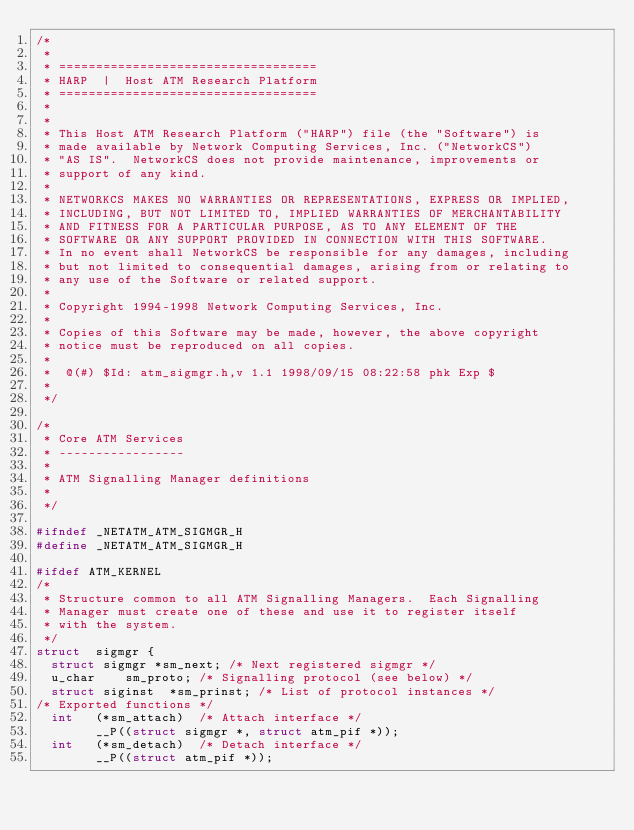<code> <loc_0><loc_0><loc_500><loc_500><_C_>/*
 *
 * ===================================
 * HARP  |  Host ATM Research Platform
 * ===================================
 *
 *
 * This Host ATM Research Platform ("HARP") file (the "Software") is
 * made available by Network Computing Services, Inc. ("NetworkCS")
 * "AS IS".  NetworkCS does not provide maintenance, improvements or
 * support of any kind.
 *
 * NETWORKCS MAKES NO WARRANTIES OR REPRESENTATIONS, EXPRESS OR IMPLIED,
 * INCLUDING, BUT NOT LIMITED TO, IMPLIED WARRANTIES OF MERCHANTABILITY
 * AND FITNESS FOR A PARTICULAR PURPOSE, AS TO ANY ELEMENT OF THE
 * SOFTWARE OR ANY SUPPORT PROVIDED IN CONNECTION WITH THIS SOFTWARE.
 * In no event shall NetworkCS be responsible for any damages, including
 * but not limited to consequential damages, arising from or relating to
 * any use of the Software or related support.
 *
 * Copyright 1994-1998 Network Computing Services, Inc.
 *
 * Copies of this Software may be made, however, the above copyright
 * notice must be reproduced on all copies.
 *
 *	@(#) $Id: atm_sigmgr.h,v 1.1 1998/09/15 08:22:58 phk Exp $
 *
 */

/*
 * Core ATM Services
 * -----------------
 *
 * ATM Signalling Manager definitions 
 *
 */

#ifndef _NETATM_ATM_SIGMGR_H
#define _NETATM_ATM_SIGMGR_H

#ifdef ATM_KERNEL
/*
 * Structure common to all ATM Signalling Managers.  Each Signalling 
 * Manager must create one of these and use it to register itself 
 * with the system.
 */
struct	sigmgr {
	struct sigmgr	*sm_next;	/* Next registered sigmgr */
	u_char		sm_proto;	/* Signalling protocol (see below) */
	struct siginst	*sm_prinst;	/* List of protocol instances */
/* Exported functions */
	int		(*sm_attach)	/* Attach interface */
				__P((struct sigmgr *, struct atm_pif *));
	int		(*sm_detach)	/* Detach interface */
				__P((struct atm_pif *));</code> 